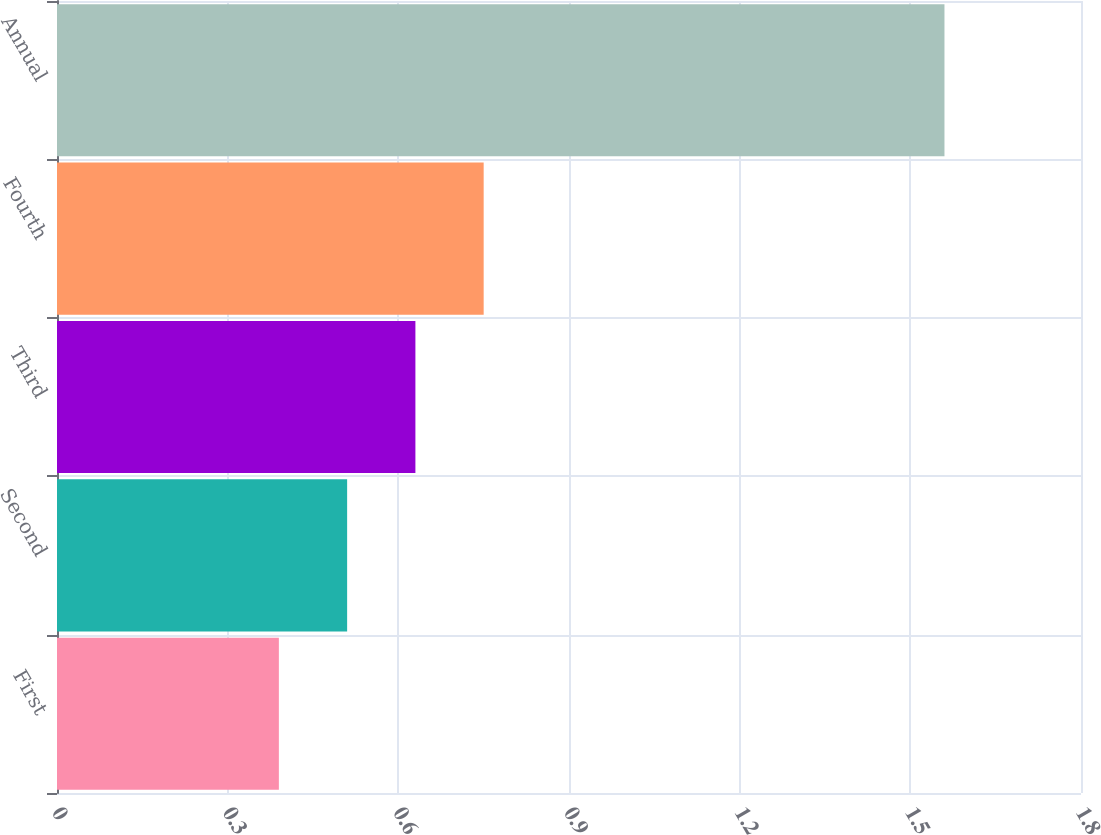<chart> <loc_0><loc_0><loc_500><loc_500><bar_chart><fcel>First<fcel>Second<fcel>Third<fcel>Fourth<fcel>Annual<nl><fcel>0.39<fcel>0.51<fcel>0.63<fcel>0.75<fcel>1.56<nl></chart> 